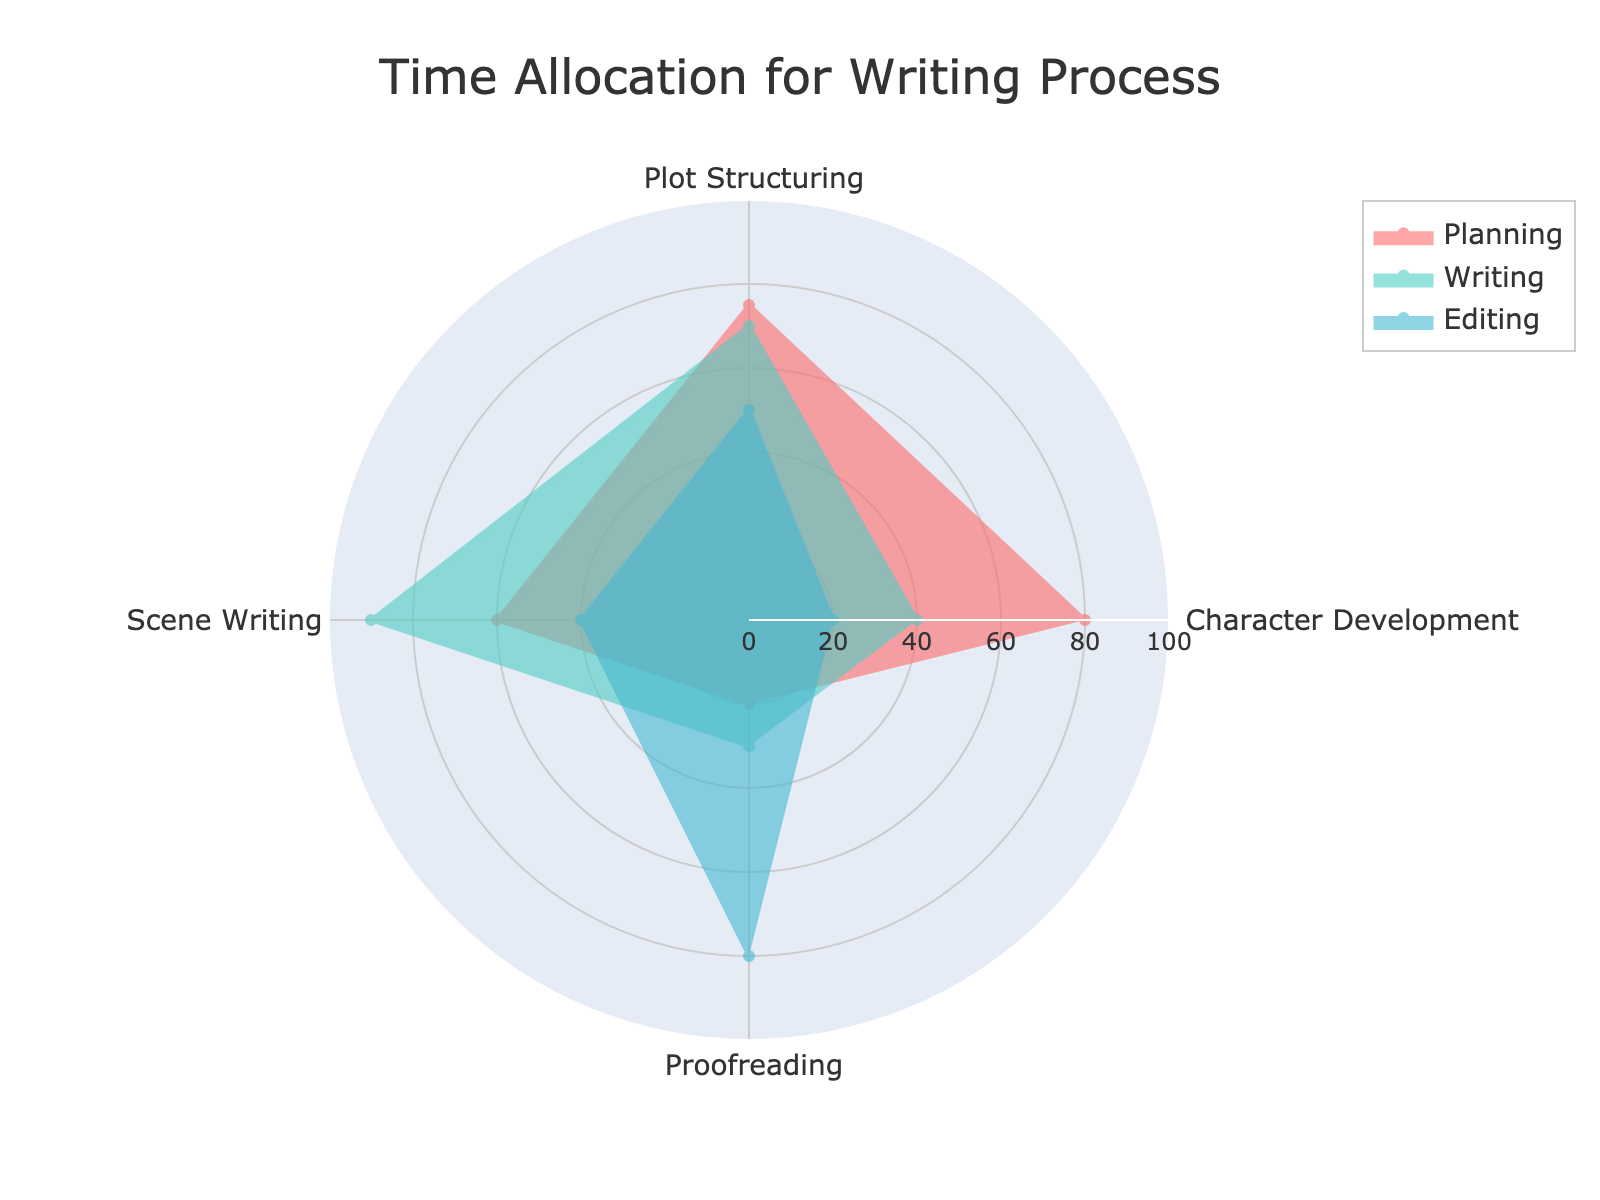What's the title of the radar chart? The title of a figure is normally displayed prominently at the top of the chart. Reviewing the chart, you can find the title easily.
Answer: Time Allocation for Writing Process How many stages are represented in the radar chart? The radar chart shows separate groups with distinct names for each stage represented on the plot. By examining the legend or the chart itself, you can count them.
Answer: 3 Which stage allocates the most time to Character Development? To determine which stage allocates the most time to Character Development, check the value under Character Development for each stage and find the maximum value.
Answer: Planning What's the average time allocated to Proofreading across all stages? To find the average, sum the time allocations for Proofreading across all stages and then divide by the number of stages. Planning (20) + Writing (30) + Editing (80) gives 130; divide by 3 for the average.
Answer: 43.33 How does the time allocation for Writing in Scene Writing compare with Planning? Compare the values for Scene Writing under both the Writing and Planning stages and see which one is higher. Writing allocates 90 while Planning allocates 60.
Answer: Higher What's the difference in allocation to Proofreading between Planning and Writing? Subtract the Proofreading allocation for the Writing stage from that of the Planning stage. Planning allocates 20, Writing allocates 30; the difference is
Answer: 10 Which stage has the lowest allocation for Plot Structuring? By looking at the values for Plot Structuring for each stage, identify the lowest value. Planning is 75, Writing is 70, Editing is 50.
Answer: Editing Is the time allocation for Plot Structuring more evenly distributed than for Proofreading? Comparing the variance of the values for each category: Plot Structuring has values 75, 70, 50, and Proofreading has values 20, 30, 80. Since the values for Plot Structuring are closer to each other, it indicates more even distribution.
Answer: Yes Which stage shows the greatest diversity in time allocation across all categories? Diversity in time allocation can be seen through the spread of the values. Compare the range (highest minus lowest value) for each stage: Planning's range (80-20)=60, Writing's range (90-30)=60, Editing's range (80-20)=60. Diversity can also be seen through standard deviation, and you may notice that no single stage stands out significantly more diverse here. But from a simplicity range angle, it is equal.
Answer: Equal What is the combined time allocated for Planning and Editing in Scene Writing? Add the time allocations for Planning and Editing stages in Scene Writing. Planning allocates 60 and Editing allocates 40; the sum is 60 + 40.
Answer: 100 